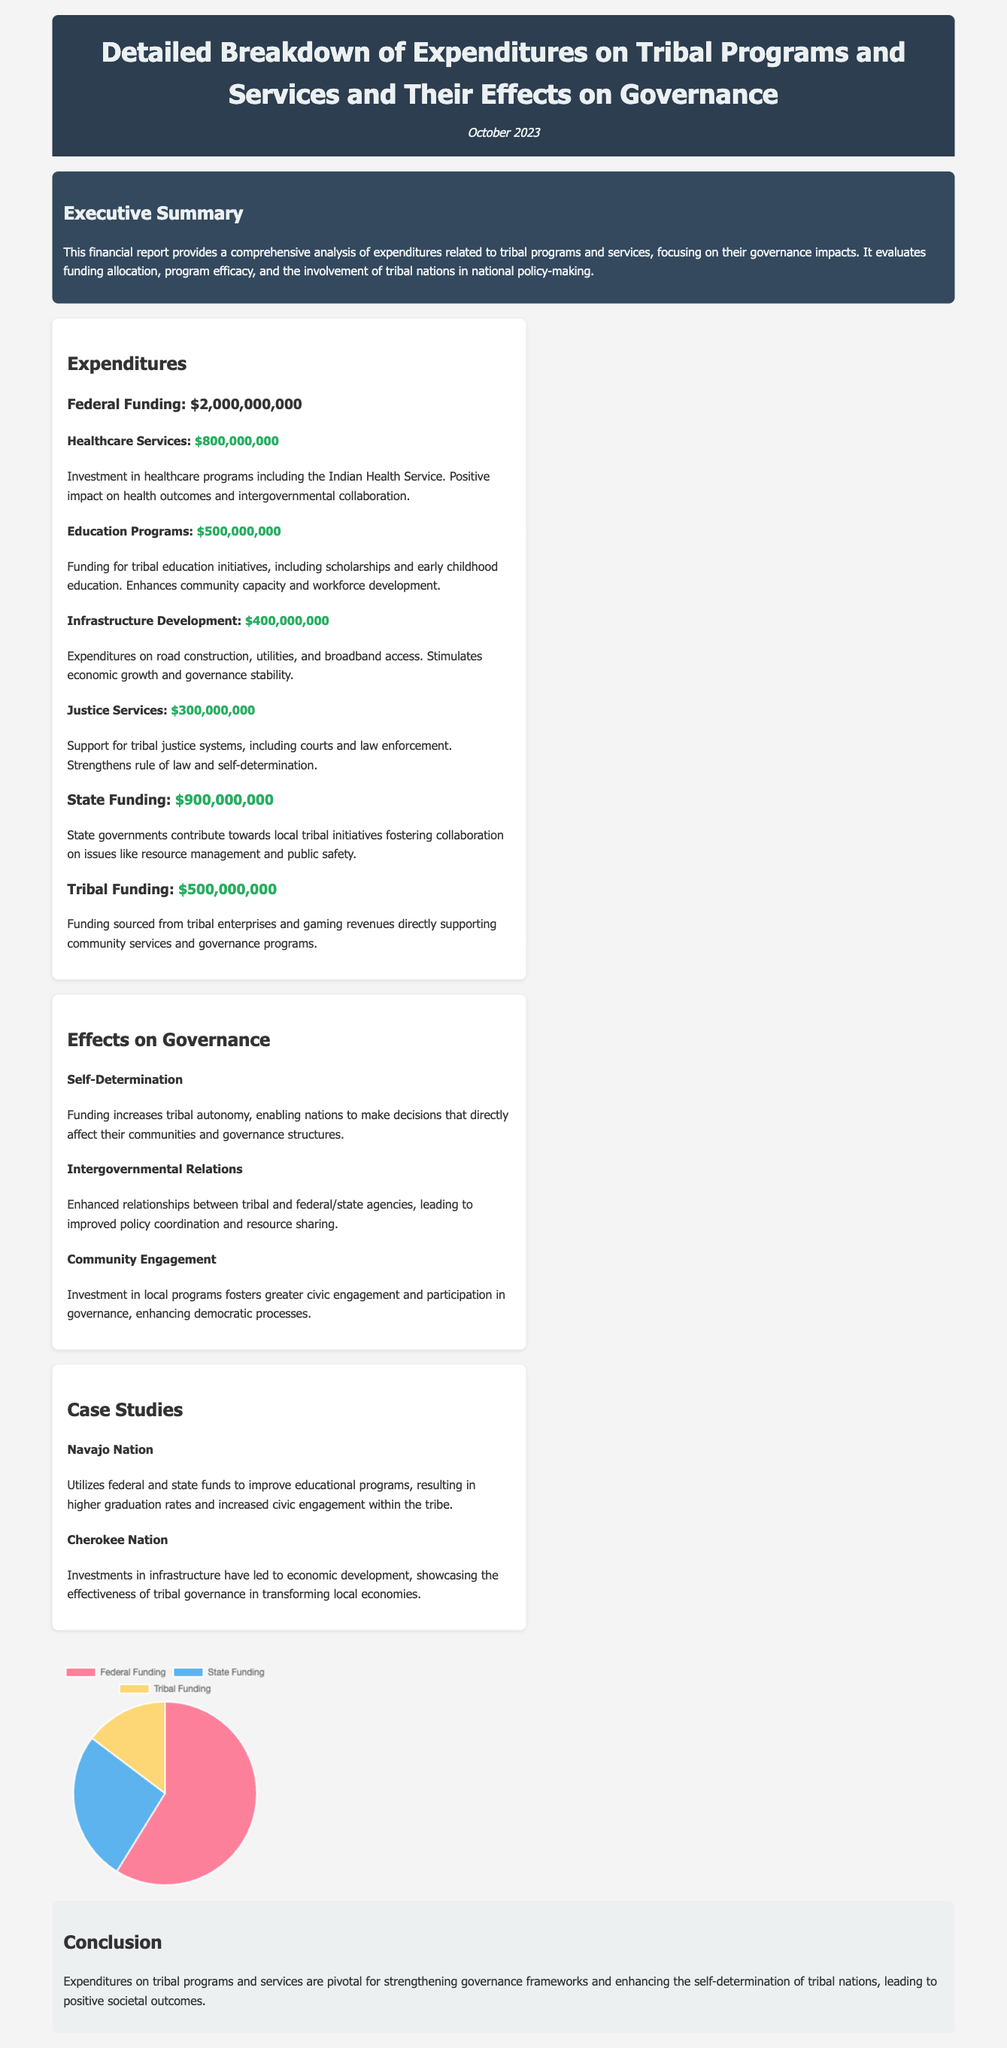What is the total federal funding? The total federal funding listed in the document is $2,000,000,000.
Answer: $2,000,000,000 How much is allocated to healthcare services? The document states that $800,000,000 is allocated to healthcare services.
Answer: $800,000,000 What impact does funding have on self-determination? The document indicates that funding increases tribal autonomy, enabling nations to make decisions that affect their communities.
Answer: Increases tribal autonomy What is the amount of state funding mentioned? The amount of state funding listed in the document is $900,000,000.
Answer: $900,000,000 Which case study highlights educational improvements? The case study of the Navajo Nation discusses improvements in educational programs and higher graduation rates.
Answer: Navajo Nation How much is spent on justice services? The expenditure for justice services is noted as $300,000,000.
Answer: $300,000,000 What is one outcome of infrastructure development funding? The document mentions that infrastructure expenditures stimulate economic growth and governance stability.
Answer: Stimulates economic growth What is the total amount of tribal funding? The document states that tribal funding amounts to $500,000,000.
Answer: $500,000,000 What type of relationships are enhanced by intergovernmental relations? The document highlights that these funding initiatives enhance relationships between tribal and federal/state agencies.
Answer: Enhanced relationships 